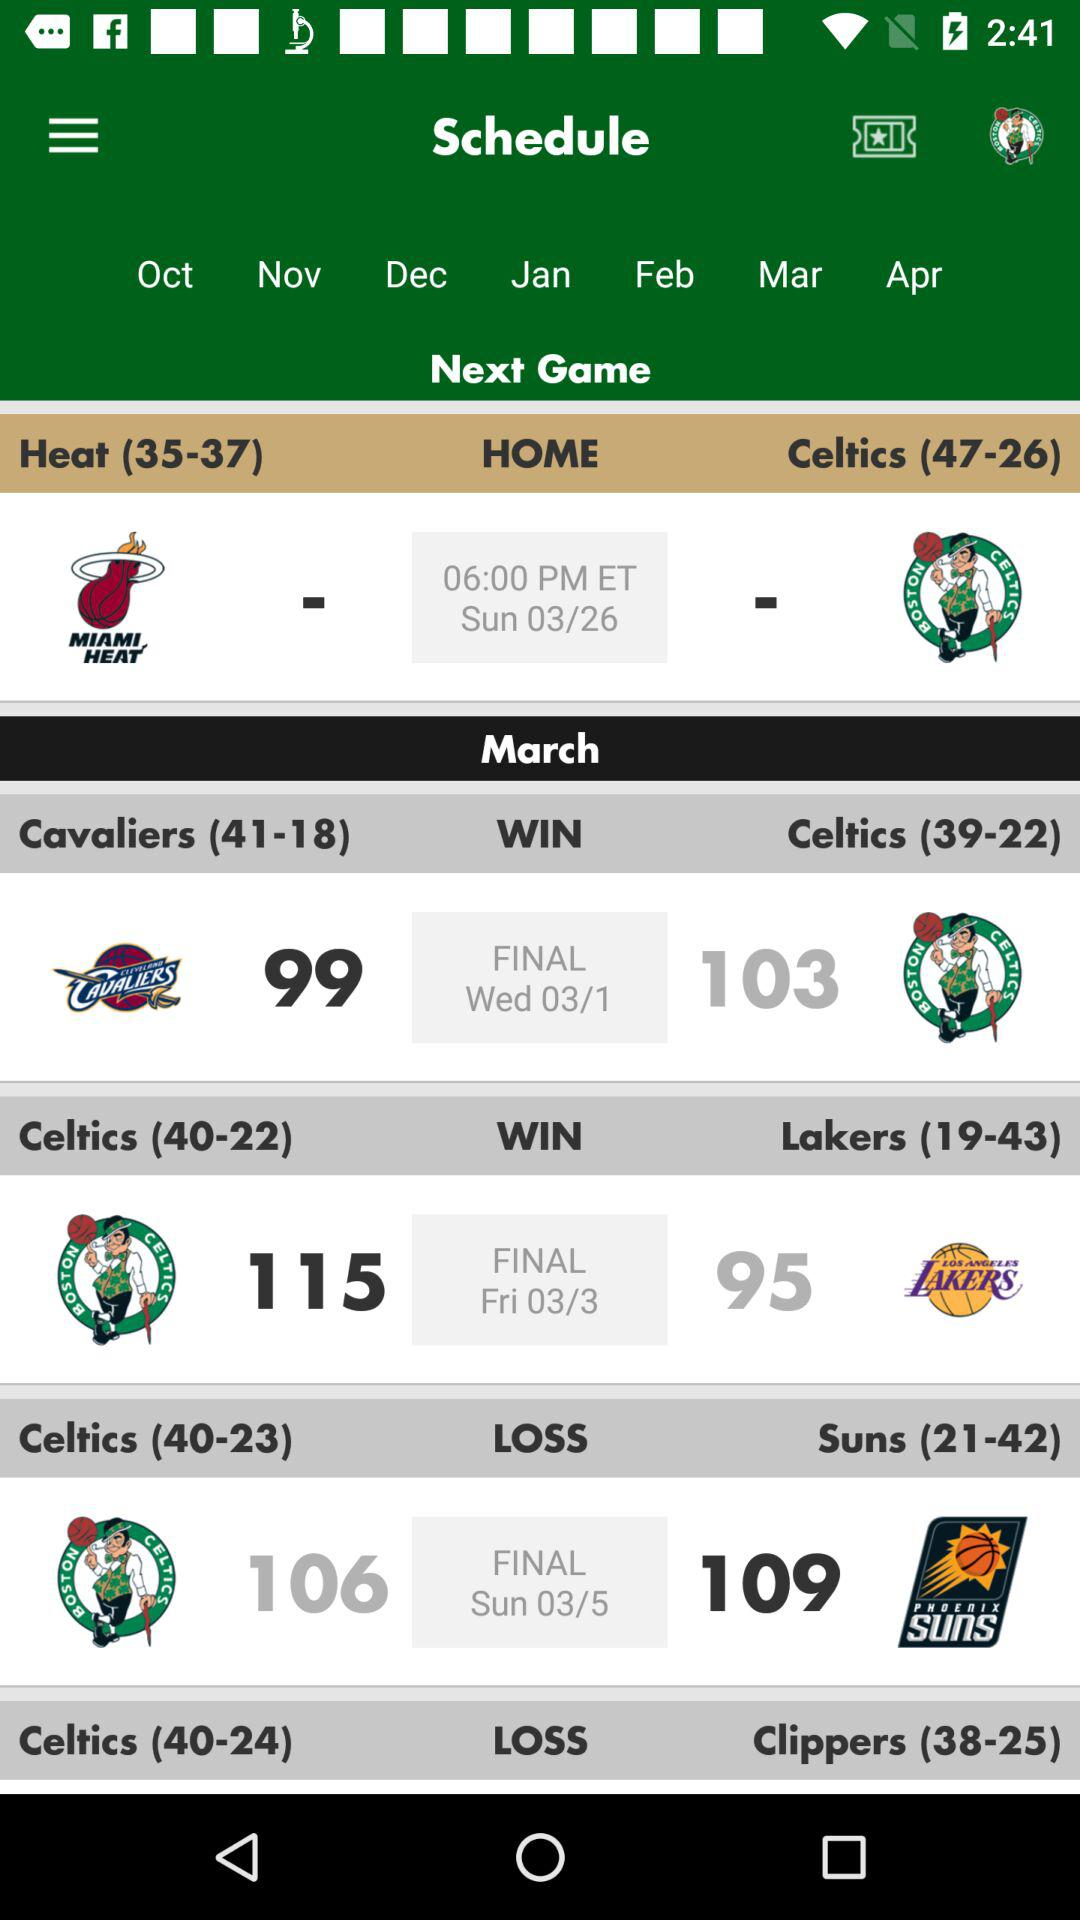What teams are playing the final match on March 3? The final match is played between the "Celtics" and "Lakers". 